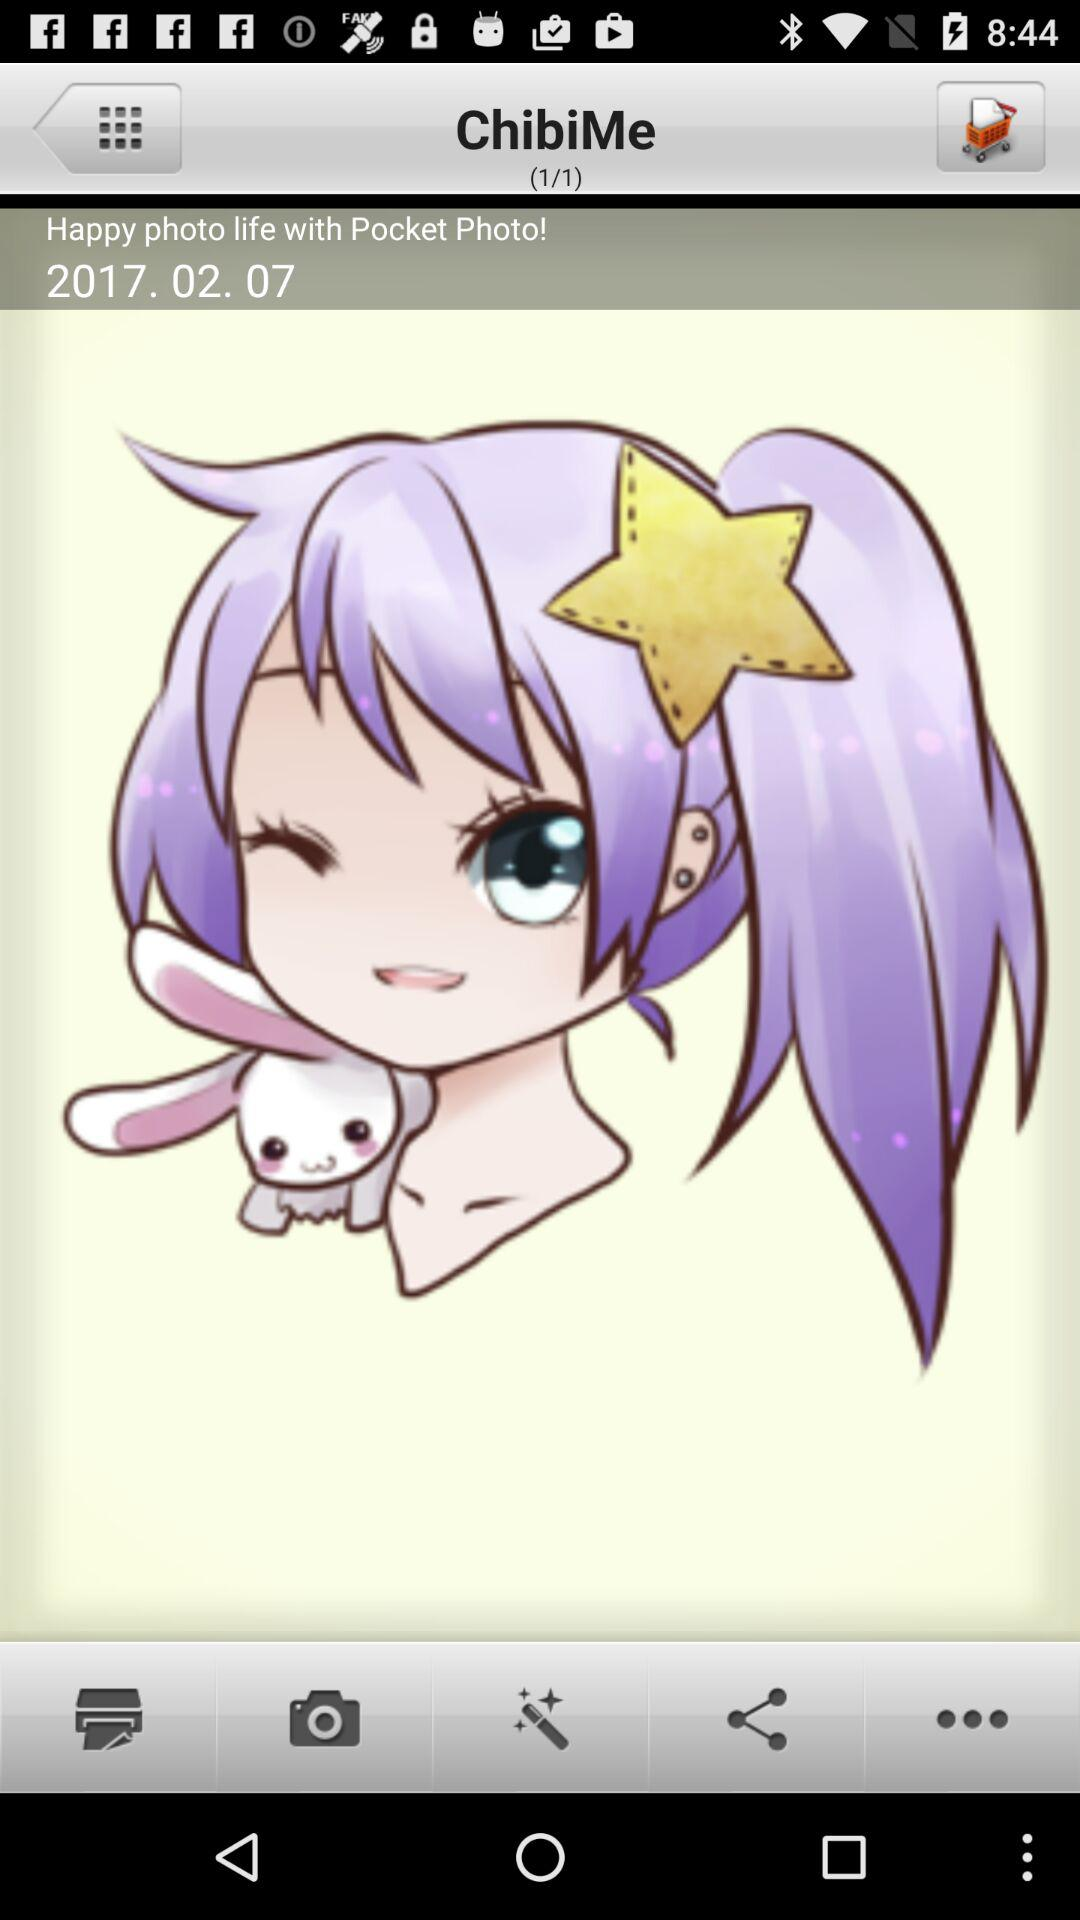What is the date? The date is 2017.02.07. 